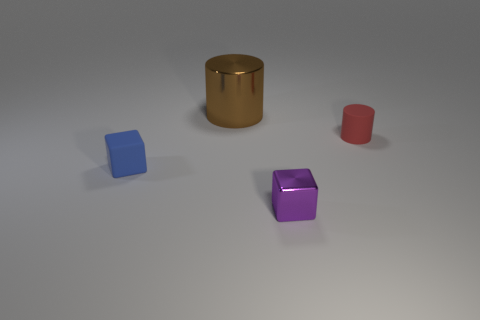Subtract all blue blocks. How many blocks are left? 1 Add 3 small cylinders. How many objects exist? 7 Subtract 2 cylinders. How many cylinders are left? 0 Add 2 tiny purple metal things. How many tiny purple metal things are left? 3 Add 3 cylinders. How many cylinders exist? 5 Subtract 0 green cylinders. How many objects are left? 4 Subtract all brown cylinders. Subtract all blue cubes. How many cylinders are left? 1 Subtract all tiny blue cylinders. Subtract all tiny purple cubes. How many objects are left? 3 